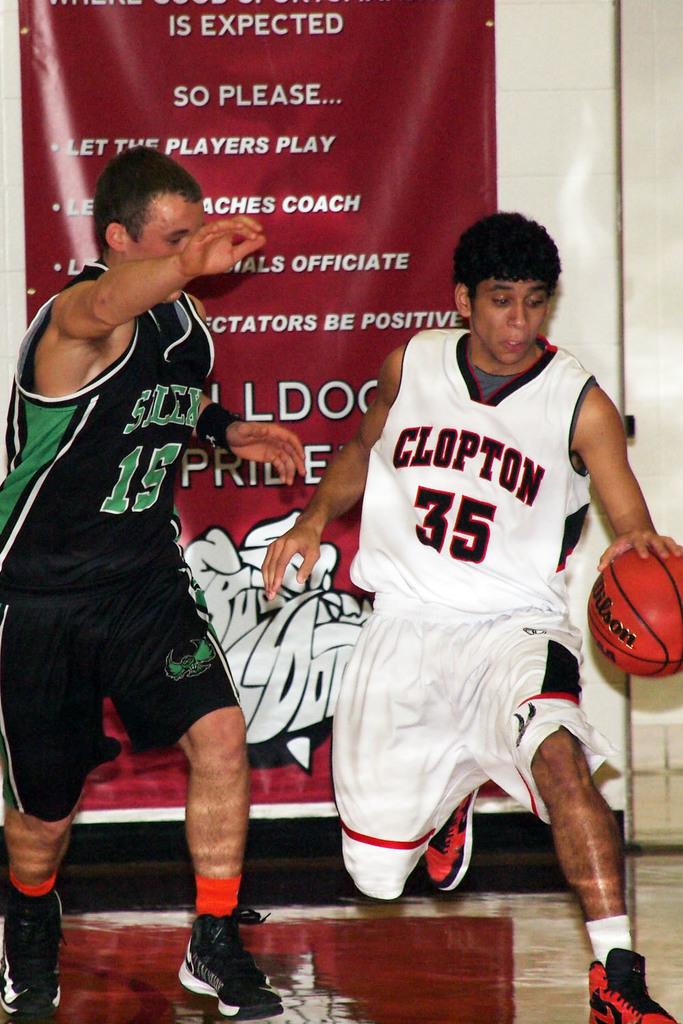What is the number of the clopton player?
Your response must be concise. 35. 